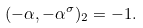Convert formula to latex. <formula><loc_0><loc_0><loc_500><loc_500>( - \alpha , - \alpha ^ { \sigma } ) _ { 2 } = - 1 .</formula> 